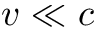Convert formula to latex. <formula><loc_0><loc_0><loc_500><loc_500>v \ll c</formula> 